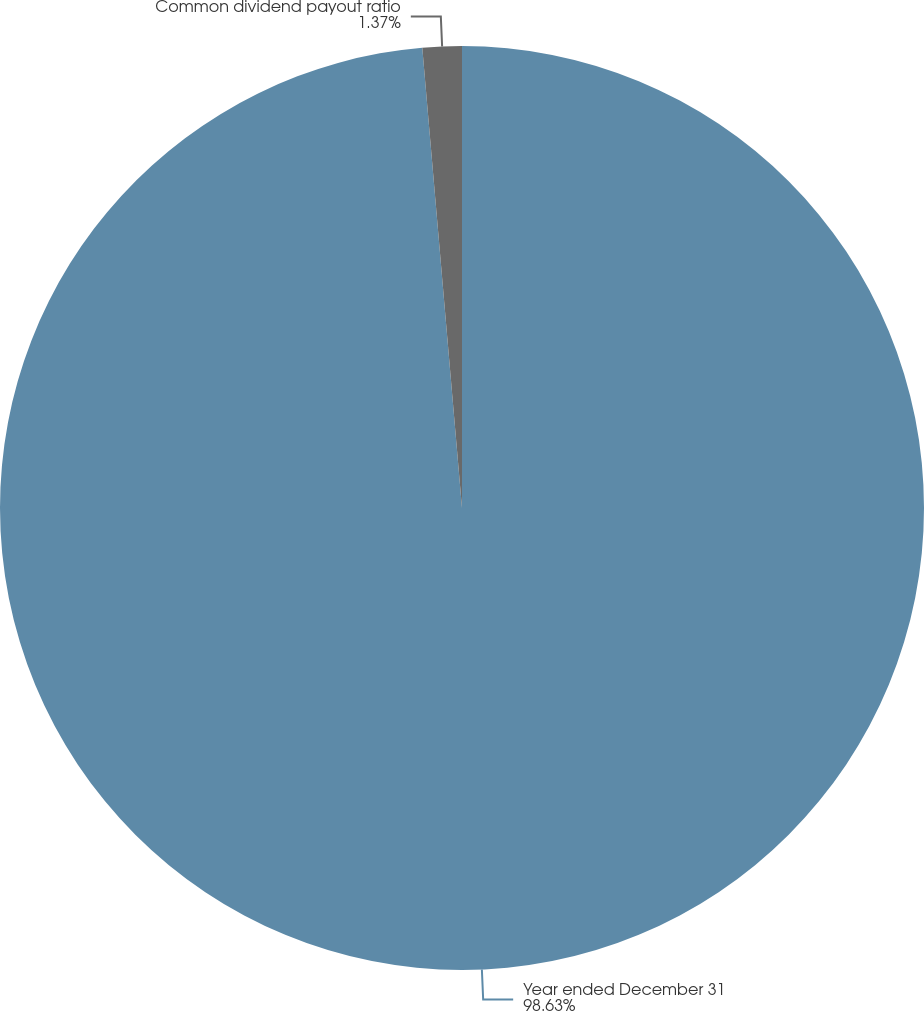<chart> <loc_0><loc_0><loc_500><loc_500><pie_chart><fcel>Year ended December 31<fcel>Common dividend payout ratio<nl><fcel>98.63%<fcel>1.37%<nl></chart> 